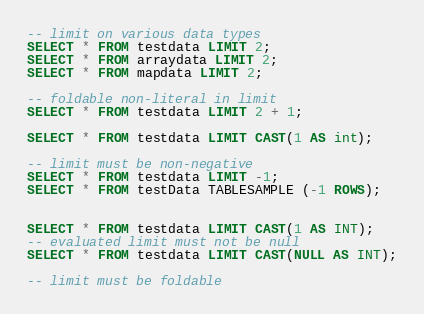<code> <loc_0><loc_0><loc_500><loc_500><_SQL_>
-- limit on various data types
SELECT * FROM testdata LIMIT 2;
SELECT * FROM arraydata LIMIT 2;
SELECT * FROM mapdata LIMIT 2;

-- foldable non-literal in limit
SELECT * FROM testdata LIMIT 2 + 1;

SELECT * FROM testdata LIMIT CAST(1 AS int);

-- limit must be non-negative
SELECT * FROM testdata LIMIT -1;
SELECT * FROM testData TABLESAMPLE (-1 ROWS);


SELECT * FROM testdata LIMIT CAST(1 AS INT);
-- evaluated limit must not be null
SELECT * FROM testdata LIMIT CAST(NULL AS INT);

-- limit must be foldable</code> 